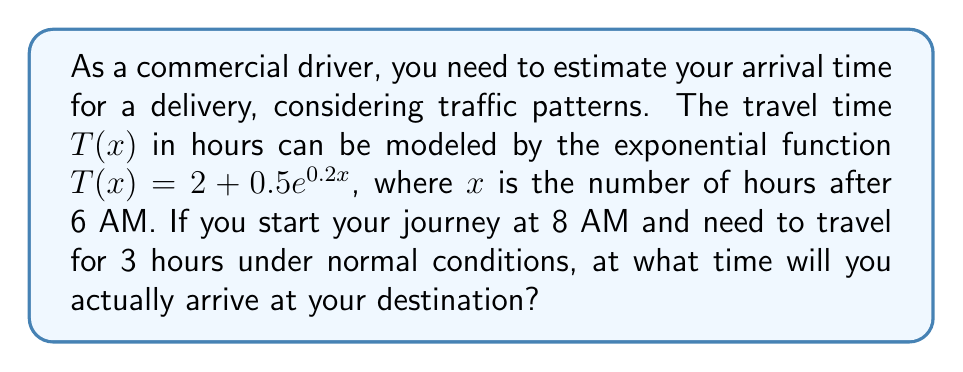Could you help me with this problem? Let's approach this step-by-step:

1) First, we need to determine the value of $x$ when you start your journey. Since $x$ is the number of hours after 6 AM, and you start at 8 AM:
   $x = 8\text{ AM} - 6\text{ AM} = 2$ hours

2) Now, we can calculate the travel time using the given function:
   $T(2) = 2 + 0.5e^{0.2(2)}$
   $= 2 + 0.5e^{0.4}$
   $\approx 2 + 0.5(1.4918)$
   $\approx 2 + 0.7459$
   $\approx 2.7459$ hours

3) This means that what normally takes 3 hours will now take approximately 2.7459 hours due to traffic patterns.

4) To find the arrival time, we add this travel time to our start time:
   $8\text{ AM} + 2.7459\text{ hours}$

5) Convert 0.7459 hours to minutes:
   $0.7459 \times 60 \approx 44.75$ minutes

6) Therefore, the arrival time is approximately 10:45 AM.
Answer: 10:45 AM 